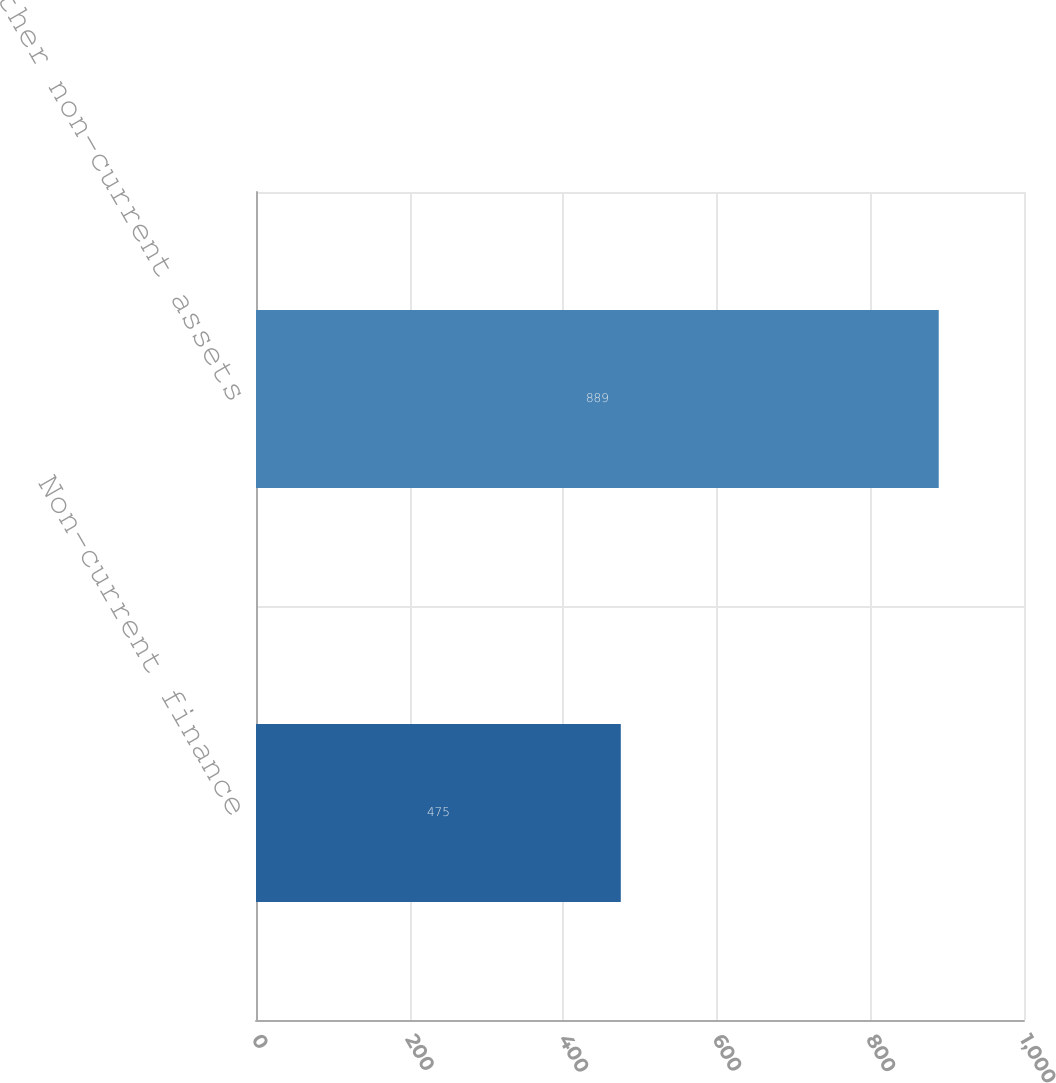<chart> <loc_0><loc_0><loc_500><loc_500><bar_chart><fcel>Non-current finance<fcel>Other non-current assets<nl><fcel>475<fcel>889<nl></chart> 